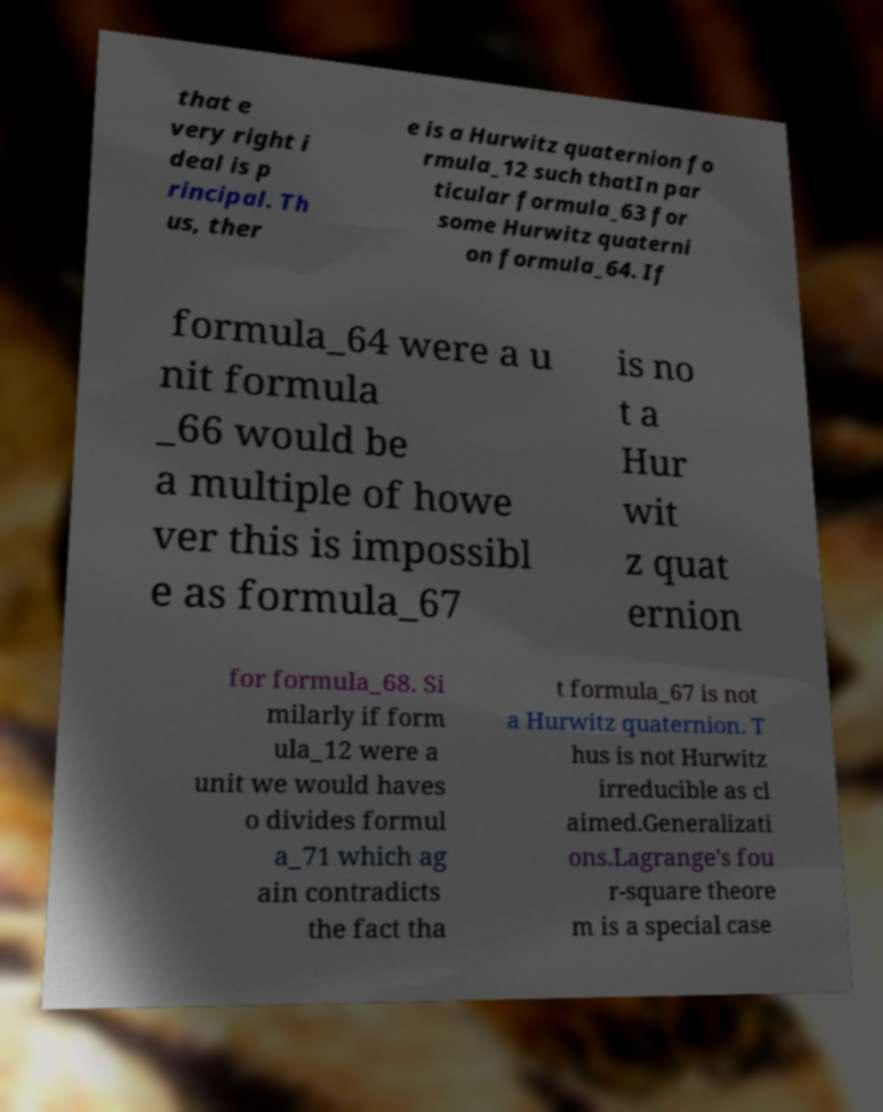Could you extract and type out the text from this image? that e very right i deal is p rincipal. Th us, ther e is a Hurwitz quaternion fo rmula_12 such thatIn par ticular formula_63 for some Hurwitz quaterni on formula_64. If formula_64 were a u nit formula _66 would be a multiple of howe ver this is impossibl e as formula_67 is no t a Hur wit z quat ernion for formula_68. Si milarly if form ula_12 were a unit we would haves o divides formul a_71 which ag ain contradicts the fact tha t formula_67 is not a Hurwitz quaternion. T hus is not Hurwitz irreducible as cl aimed.Generalizati ons.Lagrange's fou r-square theore m is a special case 